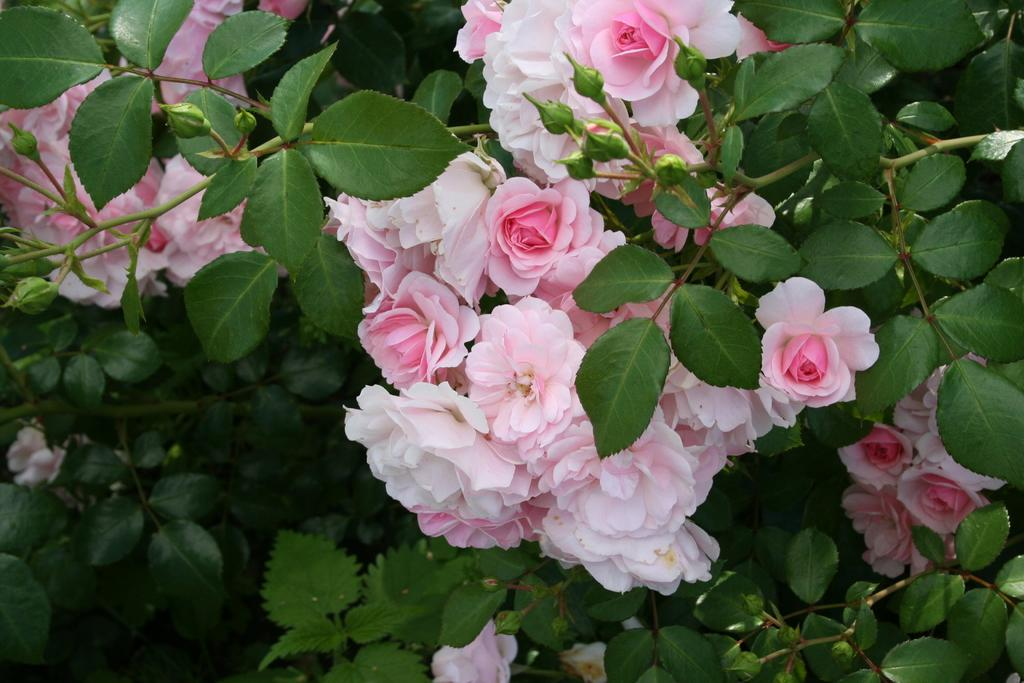What type of living organisms can be seen in the image? There are flowers and plants visible in the image. Can you describe the plants in the image? The plants in the image are not specified, but they are present alongside the flowers. What is the length of the chin visible in the image? There is no chin present in the image; it features flowers and plants. Can you describe the chess game taking place in the image? There is no chess game present in the image; it features flowers and plants. 